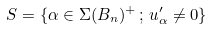Convert formula to latex. <formula><loc_0><loc_0><loc_500><loc_500>S = \{ \alpha \in \Sigma ( B _ { n } ) ^ { + } \, ; \, u _ { \alpha } ^ { \prime } \ne 0 \}</formula> 